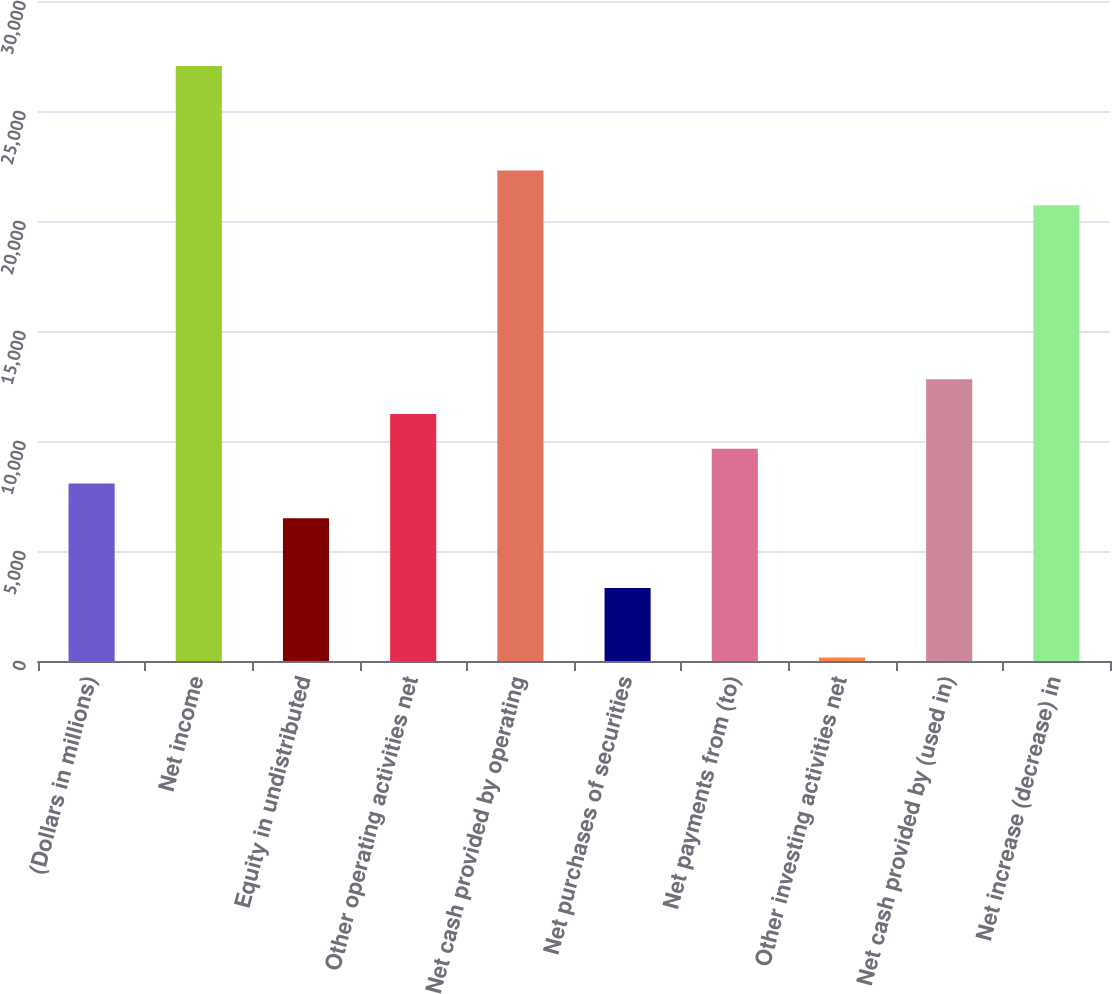<chart> <loc_0><loc_0><loc_500><loc_500><bar_chart><fcel>(Dollars in millions)<fcel>Net income<fcel>Equity in undistributed<fcel>Other operating activities net<fcel>Net cash provided by operating<fcel>Net purchases of securities<fcel>Net payments from (to)<fcel>Other investing activities net<fcel>Net cash provided by (used in)<fcel>Net increase (decrease) in<nl><fcel>8065.5<fcel>27043.5<fcel>6484<fcel>11228.5<fcel>22299<fcel>3321<fcel>9647<fcel>158<fcel>12810<fcel>20717.5<nl></chart> 